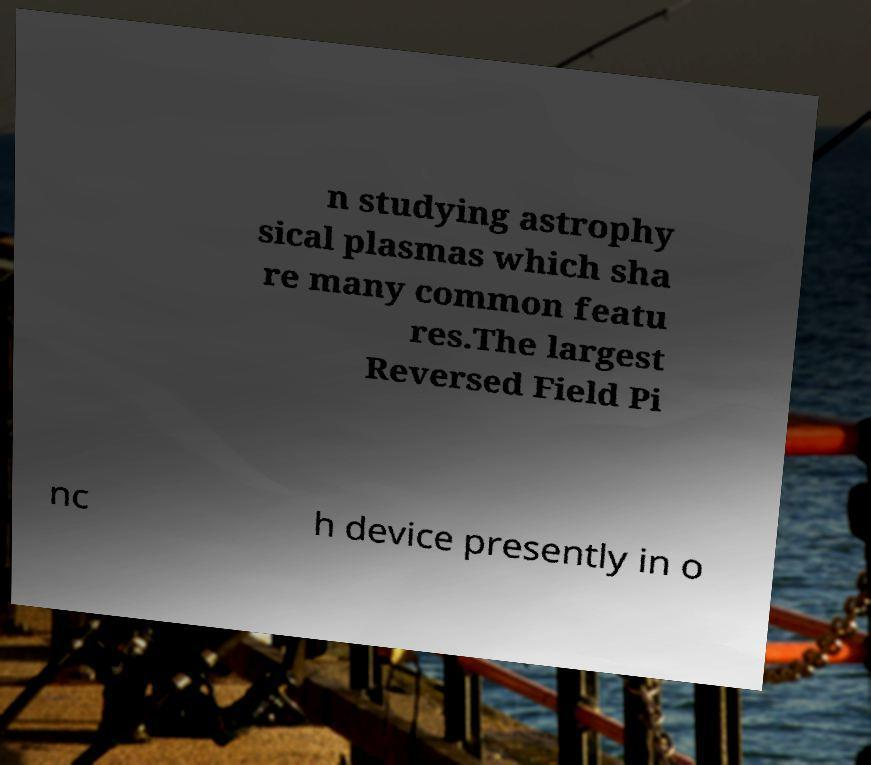Could you assist in decoding the text presented in this image and type it out clearly? n studying astrophy sical plasmas which sha re many common featu res.The largest Reversed Field Pi nc h device presently in o 